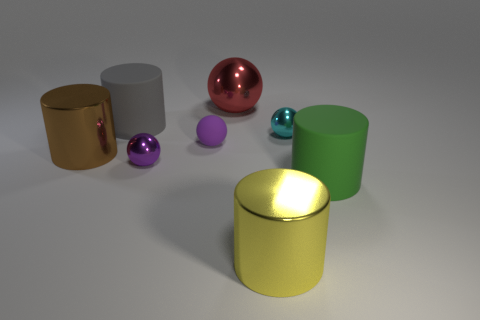What number of other objects are the same material as the tiny cyan ball?
Give a very brief answer. 4. The purple metal object behind the matte cylinder in front of the large brown cylinder is what shape?
Give a very brief answer. Sphere. There is a rubber object right of the big red object; what size is it?
Keep it short and to the point. Large. Is the material of the cyan object the same as the large red object?
Make the answer very short. Yes. There is a yellow object that is the same material as the tiny cyan sphere; what shape is it?
Offer a very short reply. Cylinder. Is there anything else of the same color as the large sphere?
Offer a terse response. No. The matte cylinder to the left of the large green rubber thing is what color?
Provide a short and direct response. Gray. There is a tiny metal ball on the left side of the large yellow cylinder; does it have the same color as the small rubber ball?
Your answer should be compact. Yes. What material is the big green object that is the same shape as the big brown shiny thing?
Your answer should be compact. Rubber. How many green rubber things are the same size as the red sphere?
Your answer should be very brief. 1. 